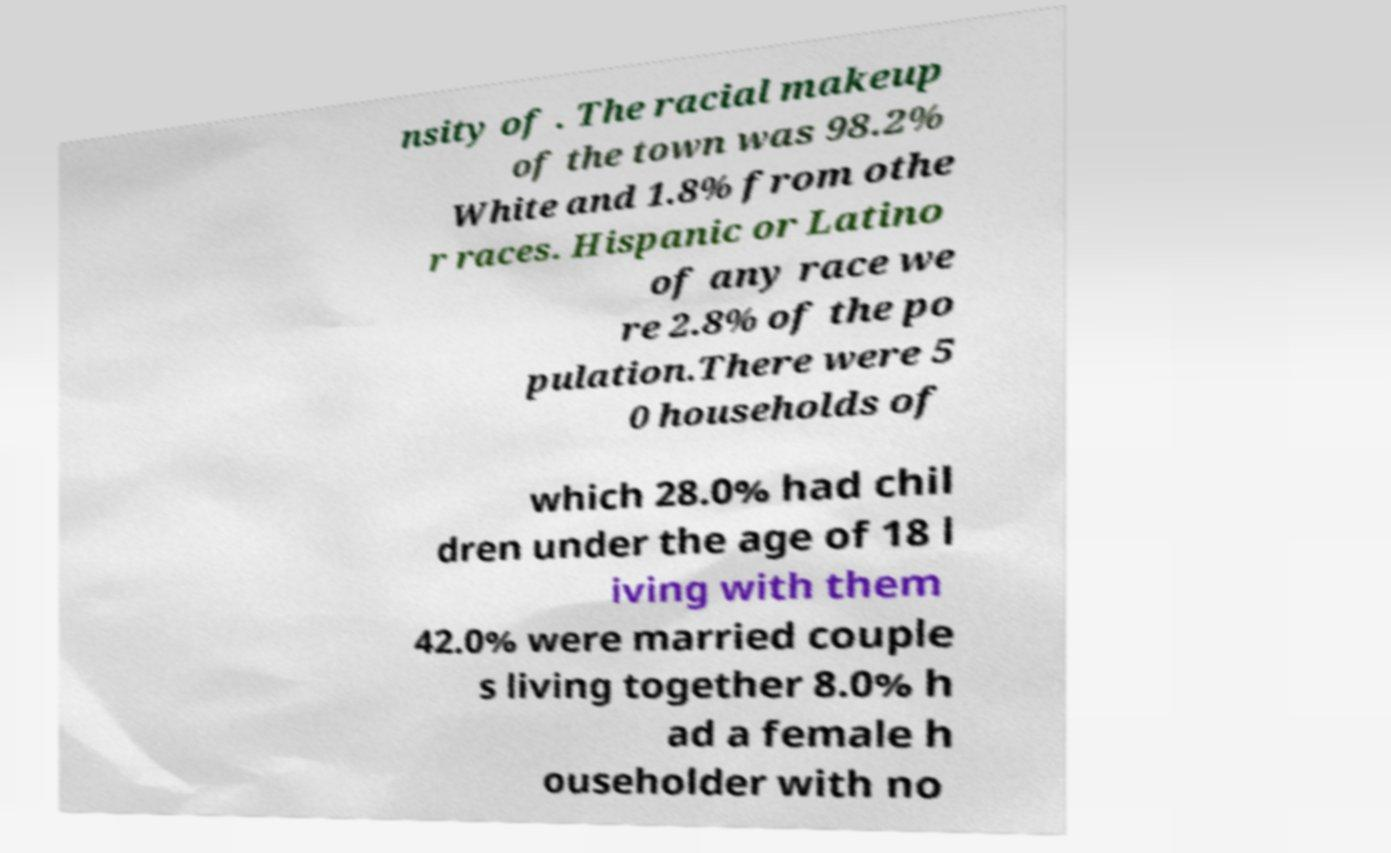Please identify and transcribe the text found in this image. nsity of . The racial makeup of the town was 98.2% White and 1.8% from othe r races. Hispanic or Latino of any race we re 2.8% of the po pulation.There were 5 0 households of which 28.0% had chil dren under the age of 18 l iving with them 42.0% were married couple s living together 8.0% h ad a female h ouseholder with no 